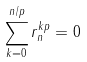<formula> <loc_0><loc_0><loc_500><loc_500>\sum _ { k = 0 } ^ { n / p } r _ { n } ^ { k p } = 0</formula> 